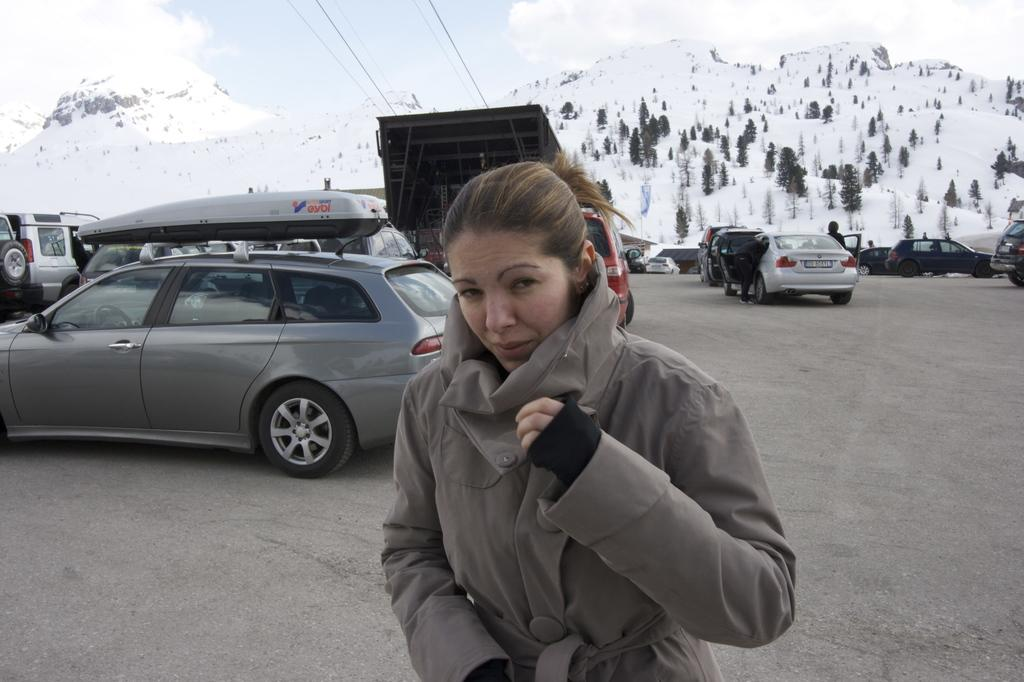What is the person in the image wearing? The person in the image is wearing a grey dress. What can be seen in the background of the image? Vehicles, wires, and trees are visible in the background. What is the weather like in the image? Snow is present in the image, indicating a cold or wintry weather condition. What is the color of the sky in the image? The sky is blue and white in color. What sense does the person in the image use to roll the snowball? The person in the image does not appear to be rolling a snowball, so it is not possible to determine which sense they might use. 